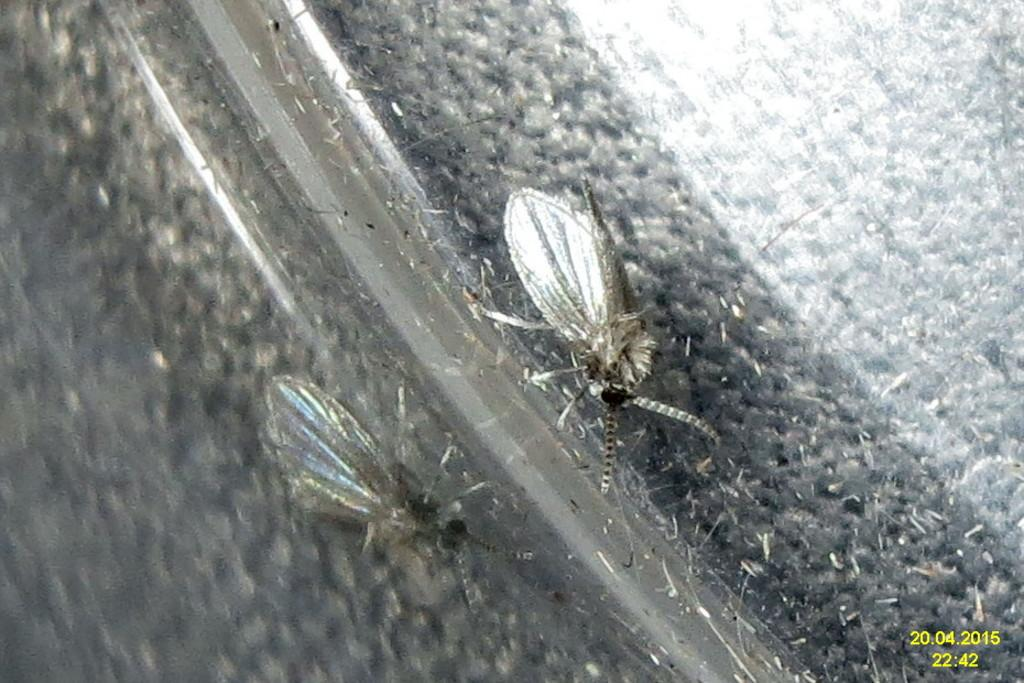What insects can be seen in the image? There are two mosquitoes in the image. Where are the mosquitoes located? The mosquitoes are lying on a road. What type of band is playing music in the image? There is no band present in the image; it features two mosquitoes lying on a road. 